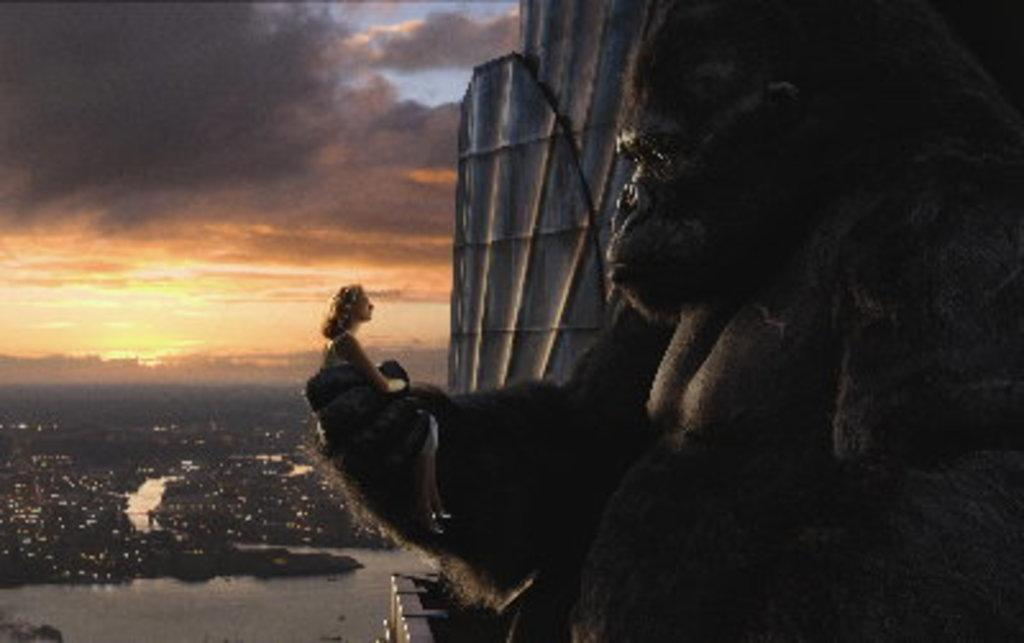What is the animal doing in the image? The animal is holding a lady in the image. What can be seen in the background of the image? There is a building in the background of the image. What part of the natural environment is visible in the image? The sky is visible in the image. What is present at the bottom of the image? There is water at the bottom of the image. What type of wine is being served in the image? There is no wine present in the image. How many yams are visible in the image? There are no yams present in the image. 